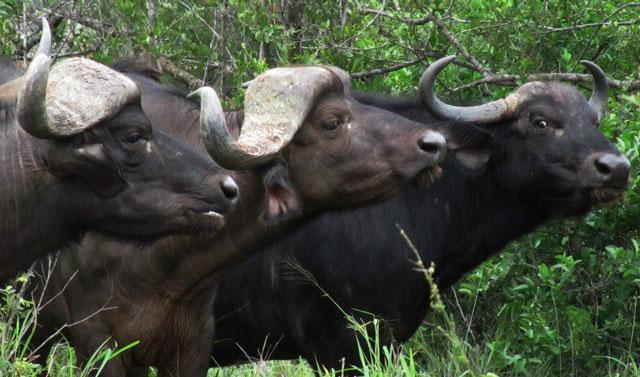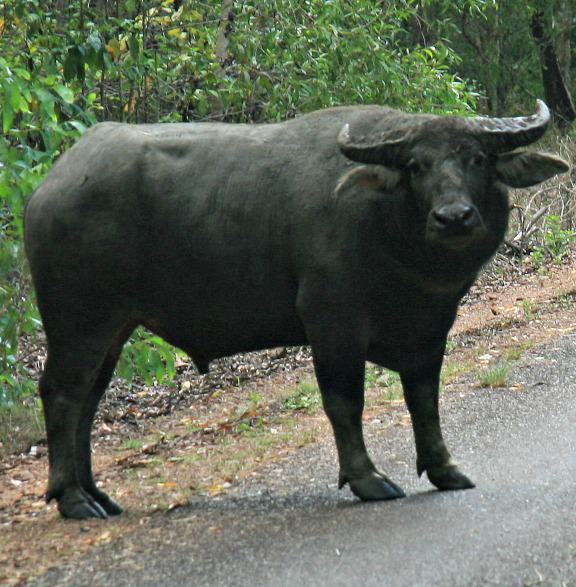The first image is the image on the left, the second image is the image on the right. For the images displayed, is the sentence "At least one image shows a buffalo in the water." factually correct? Answer yes or no. No. The first image is the image on the left, the second image is the image on the right. Assess this claim about the two images: "In one of the image a water buffalo is standing in the water.". Correct or not? Answer yes or no. No. 